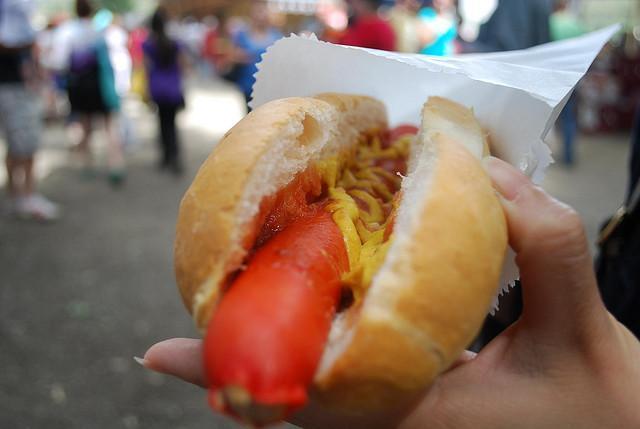How many people are visible?
Give a very brief answer. 9. 